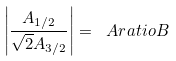<formula> <loc_0><loc_0><loc_500><loc_500>\left | \frac { A _ { 1 / 2 } } { \sqrt { 2 } A _ { 3 / 2 } } \right | = \ A r a t i o B</formula> 